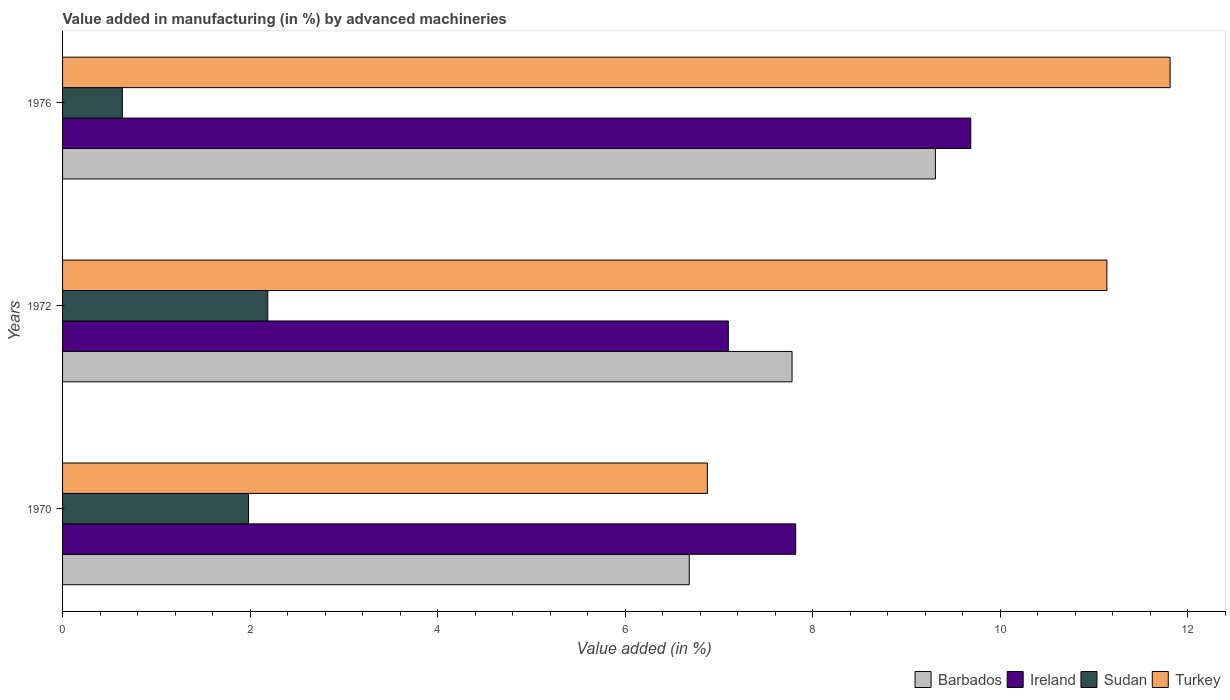How many different coloured bars are there?
Your response must be concise. 4. Are the number of bars on each tick of the Y-axis equal?
Your response must be concise. Yes. What is the percentage of value added in manufacturing by advanced machineries in Turkey in 1970?
Your response must be concise. 6.88. Across all years, what is the maximum percentage of value added in manufacturing by advanced machineries in Barbados?
Keep it short and to the point. 9.31. Across all years, what is the minimum percentage of value added in manufacturing by advanced machineries in Turkey?
Offer a very short reply. 6.88. In which year was the percentage of value added in manufacturing by advanced machineries in Sudan minimum?
Offer a terse response. 1976. What is the total percentage of value added in manufacturing by advanced machineries in Ireland in the graph?
Offer a terse response. 24.6. What is the difference between the percentage of value added in manufacturing by advanced machineries in Sudan in 1970 and that in 1976?
Your answer should be compact. 1.35. What is the difference between the percentage of value added in manufacturing by advanced machineries in Barbados in 1976 and the percentage of value added in manufacturing by advanced machineries in Ireland in 1972?
Your answer should be compact. 2.21. What is the average percentage of value added in manufacturing by advanced machineries in Barbados per year?
Your answer should be very brief. 7.92. In the year 1970, what is the difference between the percentage of value added in manufacturing by advanced machineries in Sudan and percentage of value added in manufacturing by advanced machineries in Turkey?
Provide a succinct answer. -4.89. In how many years, is the percentage of value added in manufacturing by advanced machineries in Ireland greater than 6 %?
Ensure brevity in your answer.  3. What is the ratio of the percentage of value added in manufacturing by advanced machineries in Turkey in 1972 to that in 1976?
Your response must be concise. 0.94. What is the difference between the highest and the second highest percentage of value added in manufacturing by advanced machineries in Ireland?
Your answer should be very brief. 1.87. What is the difference between the highest and the lowest percentage of value added in manufacturing by advanced machineries in Turkey?
Your answer should be very brief. 4.93. What does the 2nd bar from the top in 1976 represents?
Ensure brevity in your answer.  Sudan. What does the 3rd bar from the bottom in 1976 represents?
Give a very brief answer. Sudan. How many years are there in the graph?
Make the answer very short. 3. Where does the legend appear in the graph?
Offer a very short reply. Bottom right. How many legend labels are there?
Provide a short and direct response. 4. How are the legend labels stacked?
Provide a succinct answer. Horizontal. What is the title of the graph?
Give a very brief answer. Value added in manufacturing (in %) by advanced machineries. What is the label or title of the X-axis?
Offer a terse response. Value added (in %). What is the Value added (in %) of Barbados in 1970?
Ensure brevity in your answer.  6.68. What is the Value added (in %) in Ireland in 1970?
Your answer should be very brief. 7.82. What is the Value added (in %) of Sudan in 1970?
Offer a very short reply. 1.98. What is the Value added (in %) of Turkey in 1970?
Provide a short and direct response. 6.88. What is the Value added (in %) in Barbados in 1972?
Your response must be concise. 7.78. What is the Value added (in %) in Ireland in 1972?
Offer a very short reply. 7.1. What is the Value added (in %) of Sudan in 1972?
Ensure brevity in your answer.  2.19. What is the Value added (in %) in Turkey in 1972?
Offer a very short reply. 11.14. What is the Value added (in %) of Barbados in 1976?
Your response must be concise. 9.31. What is the Value added (in %) of Ireland in 1976?
Provide a succinct answer. 9.68. What is the Value added (in %) of Sudan in 1976?
Offer a terse response. 0.64. What is the Value added (in %) of Turkey in 1976?
Your answer should be very brief. 11.81. Across all years, what is the maximum Value added (in %) in Barbados?
Ensure brevity in your answer.  9.31. Across all years, what is the maximum Value added (in %) of Ireland?
Give a very brief answer. 9.68. Across all years, what is the maximum Value added (in %) in Sudan?
Offer a very short reply. 2.19. Across all years, what is the maximum Value added (in %) of Turkey?
Your answer should be very brief. 11.81. Across all years, what is the minimum Value added (in %) of Barbados?
Give a very brief answer. 6.68. Across all years, what is the minimum Value added (in %) in Ireland?
Give a very brief answer. 7.1. Across all years, what is the minimum Value added (in %) of Sudan?
Ensure brevity in your answer.  0.64. Across all years, what is the minimum Value added (in %) of Turkey?
Keep it short and to the point. 6.88. What is the total Value added (in %) of Barbados in the graph?
Your response must be concise. 23.77. What is the total Value added (in %) in Ireland in the graph?
Provide a succinct answer. 24.6. What is the total Value added (in %) of Sudan in the graph?
Offer a very short reply. 4.81. What is the total Value added (in %) of Turkey in the graph?
Give a very brief answer. 29.82. What is the difference between the Value added (in %) in Barbados in 1970 and that in 1972?
Your response must be concise. -1.1. What is the difference between the Value added (in %) in Ireland in 1970 and that in 1972?
Ensure brevity in your answer.  0.72. What is the difference between the Value added (in %) in Sudan in 1970 and that in 1972?
Provide a succinct answer. -0.21. What is the difference between the Value added (in %) in Turkey in 1970 and that in 1972?
Provide a short and direct response. -4.26. What is the difference between the Value added (in %) in Barbados in 1970 and that in 1976?
Give a very brief answer. -2.62. What is the difference between the Value added (in %) of Ireland in 1970 and that in 1976?
Ensure brevity in your answer.  -1.87. What is the difference between the Value added (in %) in Sudan in 1970 and that in 1976?
Your answer should be very brief. 1.35. What is the difference between the Value added (in %) in Turkey in 1970 and that in 1976?
Give a very brief answer. -4.93. What is the difference between the Value added (in %) of Barbados in 1972 and that in 1976?
Give a very brief answer. -1.53. What is the difference between the Value added (in %) of Ireland in 1972 and that in 1976?
Offer a terse response. -2.59. What is the difference between the Value added (in %) of Sudan in 1972 and that in 1976?
Provide a succinct answer. 1.55. What is the difference between the Value added (in %) of Turkey in 1972 and that in 1976?
Provide a short and direct response. -0.67. What is the difference between the Value added (in %) in Barbados in 1970 and the Value added (in %) in Ireland in 1972?
Offer a very short reply. -0.42. What is the difference between the Value added (in %) in Barbados in 1970 and the Value added (in %) in Sudan in 1972?
Provide a short and direct response. 4.49. What is the difference between the Value added (in %) in Barbados in 1970 and the Value added (in %) in Turkey in 1972?
Your answer should be very brief. -4.45. What is the difference between the Value added (in %) in Ireland in 1970 and the Value added (in %) in Sudan in 1972?
Keep it short and to the point. 5.63. What is the difference between the Value added (in %) in Ireland in 1970 and the Value added (in %) in Turkey in 1972?
Provide a short and direct response. -3.32. What is the difference between the Value added (in %) of Sudan in 1970 and the Value added (in %) of Turkey in 1972?
Your answer should be compact. -9.15. What is the difference between the Value added (in %) of Barbados in 1970 and the Value added (in %) of Ireland in 1976?
Ensure brevity in your answer.  -3. What is the difference between the Value added (in %) in Barbados in 1970 and the Value added (in %) in Sudan in 1976?
Ensure brevity in your answer.  6.05. What is the difference between the Value added (in %) of Barbados in 1970 and the Value added (in %) of Turkey in 1976?
Your response must be concise. -5.13. What is the difference between the Value added (in %) in Ireland in 1970 and the Value added (in %) in Sudan in 1976?
Offer a very short reply. 7.18. What is the difference between the Value added (in %) of Ireland in 1970 and the Value added (in %) of Turkey in 1976?
Provide a succinct answer. -3.99. What is the difference between the Value added (in %) of Sudan in 1970 and the Value added (in %) of Turkey in 1976?
Offer a very short reply. -9.83. What is the difference between the Value added (in %) of Barbados in 1972 and the Value added (in %) of Ireland in 1976?
Make the answer very short. -1.91. What is the difference between the Value added (in %) of Barbados in 1972 and the Value added (in %) of Sudan in 1976?
Offer a very short reply. 7.14. What is the difference between the Value added (in %) in Barbados in 1972 and the Value added (in %) in Turkey in 1976?
Your answer should be very brief. -4.03. What is the difference between the Value added (in %) in Ireland in 1972 and the Value added (in %) in Sudan in 1976?
Make the answer very short. 6.46. What is the difference between the Value added (in %) in Ireland in 1972 and the Value added (in %) in Turkey in 1976?
Offer a very short reply. -4.71. What is the difference between the Value added (in %) in Sudan in 1972 and the Value added (in %) in Turkey in 1976?
Give a very brief answer. -9.62. What is the average Value added (in %) in Barbados per year?
Your answer should be very brief. 7.92. What is the average Value added (in %) of Ireland per year?
Your response must be concise. 8.2. What is the average Value added (in %) in Sudan per year?
Ensure brevity in your answer.  1.6. What is the average Value added (in %) in Turkey per year?
Keep it short and to the point. 9.94. In the year 1970, what is the difference between the Value added (in %) in Barbados and Value added (in %) in Ireland?
Your response must be concise. -1.14. In the year 1970, what is the difference between the Value added (in %) of Barbados and Value added (in %) of Sudan?
Provide a succinct answer. 4.7. In the year 1970, what is the difference between the Value added (in %) of Barbados and Value added (in %) of Turkey?
Your answer should be compact. -0.19. In the year 1970, what is the difference between the Value added (in %) in Ireland and Value added (in %) in Sudan?
Provide a succinct answer. 5.83. In the year 1970, what is the difference between the Value added (in %) of Ireland and Value added (in %) of Turkey?
Offer a terse response. 0.94. In the year 1970, what is the difference between the Value added (in %) of Sudan and Value added (in %) of Turkey?
Your response must be concise. -4.89. In the year 1972, what is the difference between the Value added (in %) in Barbados and Value added (in %) in Ireland?
Ensure brevity in your answer.  0.68. In the year 1972, what is the difference between the Value added (in %) of Barbados and Value added (in %) of Sudan?
Provide a succinct answer. 5.59. In the year 1972, what is the difference between the Value added (in %) in Barbados and Value added (in %) in Turkey?
Keep it short and to the point. -3.36. In the year 1972, what is the difference between the Value added (in %) of Ireland and Value added (in %) of Sudan?
Your answer should be very brief. 4.91. In the year 1972, what is the difference between the Value added (in %) in Ireland and Value added (in %) in Turkey?
Make the answer very short. -4.04. In the year 1972, what is the difference between the Value added (in %) in Sudan and Value added (in %) in Turkey?
Give a very brief answer. -8.95. In the year 1976, what is the difference between the Value added (in %) of Barbados and Value added (in %) of Ireland?
Your response must be concise. -0.38. In the year 1976, what is the difference between the Value added (in %) of Barbados and Value added (in %) of Sudan?
Offer a terse response. 8.67. In the year 1976, what is the difference between the Value added (in %) in Barbados and Value added (in %) in Turkey?
Offer a terse response. -2.5. In the year 1976, what is the difference between the Value added (in %) of Ireland and Value added (in %) of Sudan?
Keep it short and to the point. 9.05. In the year 1976, what is the difference between the Value added (in %) in Ireland and Value added (in %) in Turkey?
Keep it short and to the point. -2.13. In the year 1976, what is the difference between the Value added (in %) in Sudan and Value added (in %) in Turkey?
Your answer should be very brief. -11.17. What is the ratio of the Value added (in %) in Barbados in 1970 to that in 1972?
Provide a succinct answer. 0.86. What is the ratio of the Value added (in %) in Ireland in 1970 to that in 1972?
Keep it short and to the point. 1.1. What is the ratio of the Value added (in %) of Sudan in 1970 to that in 1972?
Make the answer very short. 0.91. What is the ratio of the Value added (in %) of Turkey in 1970 to that in 1972?
Give a very brief answer. 0.62. What is the ratio of the Value added (in %) of Barbados in 1970 to that in 1976?
Provide a succinct answer. 0.72. What is the ratio of the Value added (in %) of Ireland in 1970 to that in 1976?
Offer a terse response. 0.81. What is the ratio of the Value added (in %) in Sudan in 1970 to that in 1976?
Provide a short and direct response. 3.11. What is the ratio of the Value added (in %) in Turkey in 1970 to that in 1976?
Provide a short and direct response. 0.58. What is the ratio of the Value added (in %) of Barbados in 1972 to that in 1976?
Keep it short and to the point. 0.84. What is the ratio of the Value added (in %) in Ireland in 1972 to that in 1976?
Provide a short and direct response. 0.73. What is the ratio of the Value added (in %) in Sudan in 1972 to that in 1976?
Your answer should be very brief. 3.43. What is the ratio of the Value added (in %) in Turkey in 1972 to that in 1976?
Provide a succinct answer. 0.94. What is the difference between the highest and the second highest Value added (in %) of Barbados?
Your response must be concise. 1.53. What is the difference between the highest and the second highest Value added (in %) of Ireland?
Your answer should be very brief. 1.87. What is the difference between the highest and the second highest Value added (in %) of Sudan?
Give a very brief answer. 0.21. What is the difference between the highest and the second highest Value added (in %) in Turkey?
Your answer should be very brief. 0.67. What is the difference between the highest and the lowest Value added (in %) of Barbados?
Provide a succinct answer. 2.62. What is the difference between the highest and the lowest Value added (in %) of Ireland?
Make the answer very short. 2.59. What is the difference between the highest and the lowest Value added (in %) in Sudan?
Give a very brief answer. 1.55. What is the difference between the highest and the lowest Value added (in %) in Turkey?
Provide a succinct answer. 4.93. 